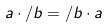Convert formula to latex. <formula><loc_0><loc_0><loc_500><loc_500>a \cdot / b = / b \cdot a</formula> 